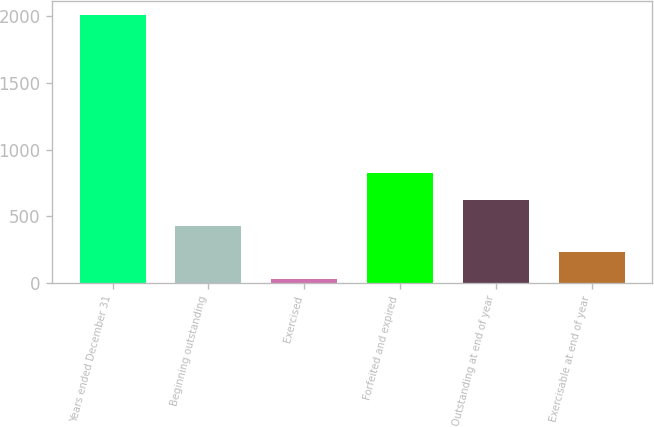Convert chart to OTSL. <chart><loc_0><loc_0><loc_500><loc_500><bar_chart><fcel>Years ended December 31<fcel>Beginning outstanding<fcel>Exercised<fcel>Forfeited and expired<fcel>Outstanding at end of year<fcel>Exercisable at end of year<nl><fcel>2012<fcel>427.2<fcel>31<fcel>823.4<fcel>625.3<fcel>229.1<nl></chart> 